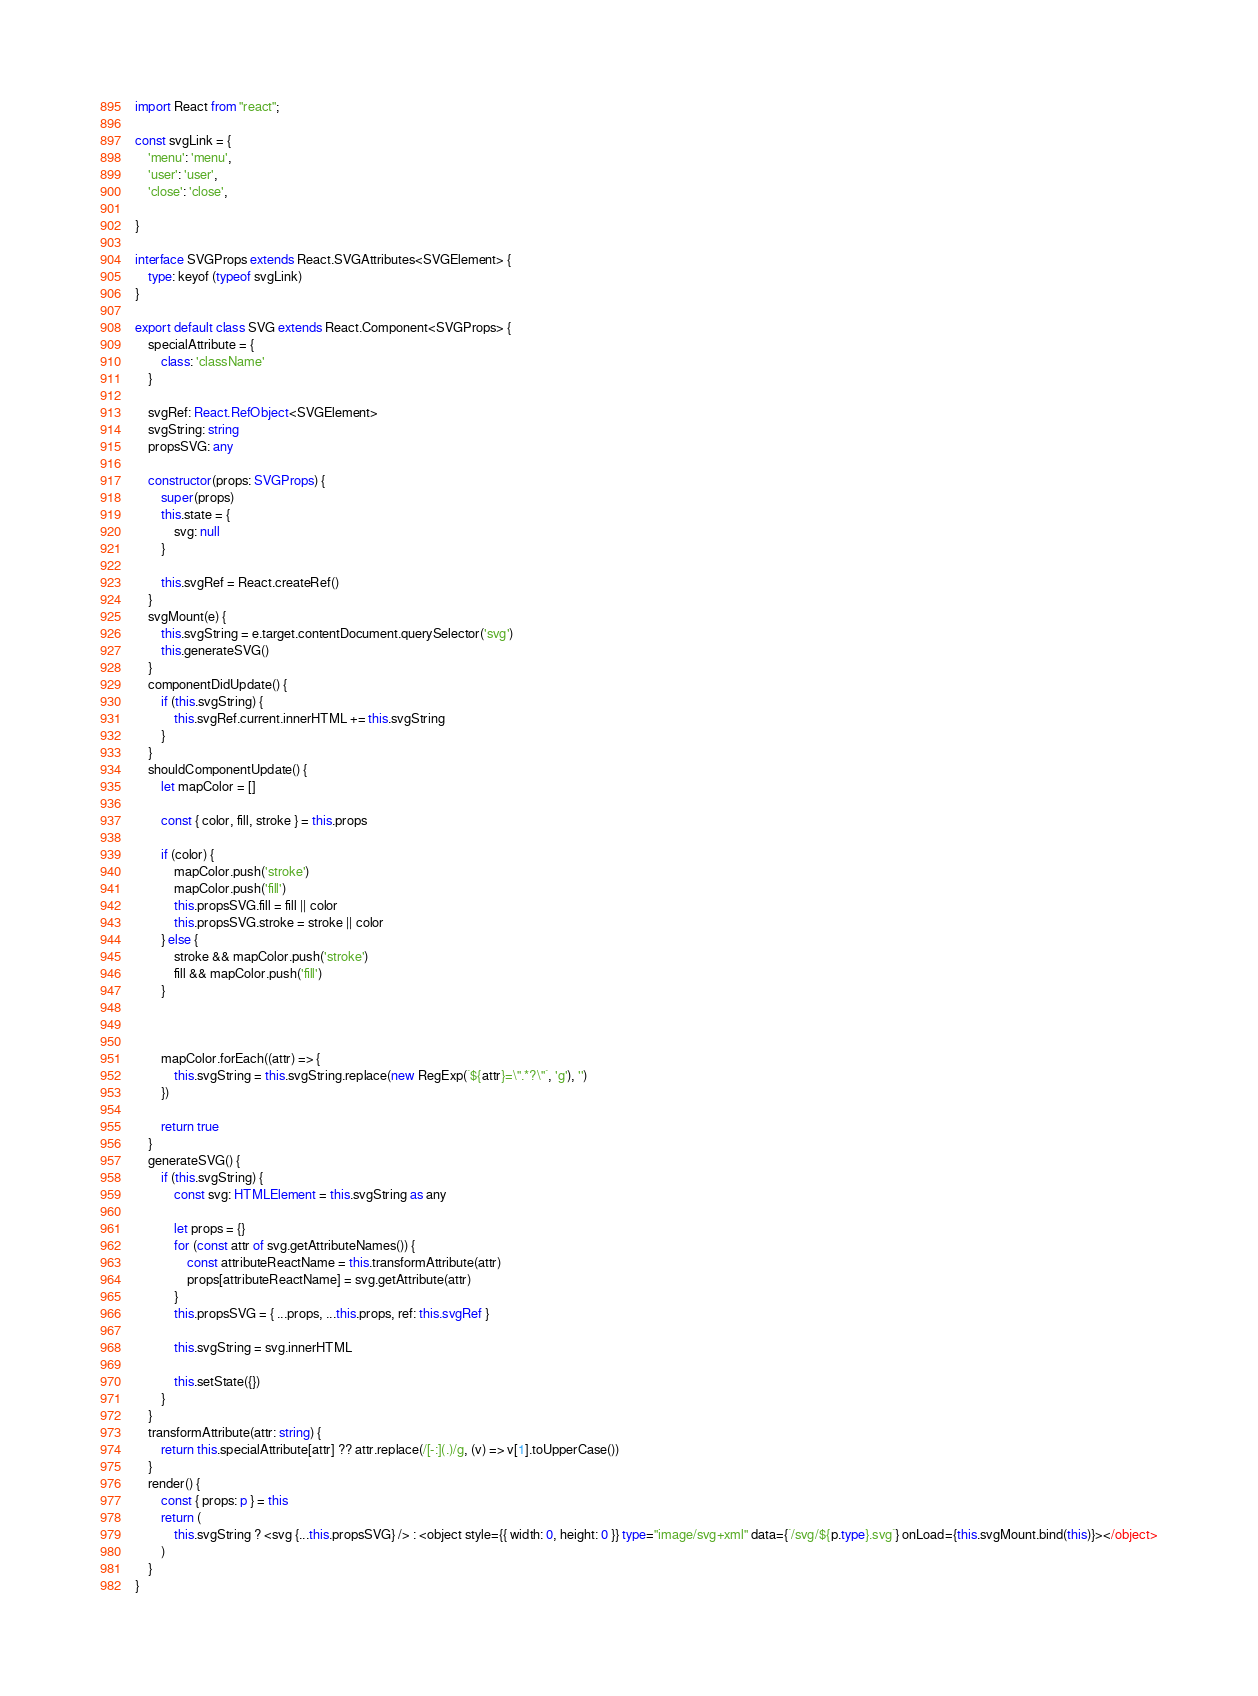Convert code to text. <code><loc_0><loc_0><loc_500><loc_500><_TypeScript_>import React from "react";

const svgLink = {
    'menu': 'menu',
    'user': 'user',
    'close': 'close',

}

interface SVGProps extends React.SVGAttributes<SVGElement> {
    type: keyof (typeof svgLink)
}

export default class SVG extends React.Component<SVGProps> {
    specialAttribute = {
        class: 'className'
    }

    svgRef: React.RefObject<SVGElement>
    svgString: string
    propsSVG: any

    constructor(props: SVGProps) {
        super(props)
        this.state = {
            svg: null
        }

        this.svgRef = React.createRef()
    }
    svgMount(e) {
        this.svgString = e.target.contentDocument.querySelector('svg')
        this.generateSVG()
    }
    componentDidUpdate() {
        if (this.svgString) {
            this.svgRef.current.innerHTML += this.svgString
        }
    }
    shouldComponentUpdate() {
        let mapColor = []

        const { color, fill, stroke } = this.props

        if (color) {
            mapColor.push('stroke')
            mapColor.push('fill')
            this.propsSVG.fill = fill || color
            this.propsSVG.stroke = stroke || color
        } else {
            stroke && mapColor.push('stroke')
            fill && mapColor.push('fill')
        }



        mapColor.forEach((attr) => {
            this.svgString = this.svgString.replace(new RegExp(`${attr}=\".*?\"`, 'g'), '')
        })

        return true
    }
    generateSVG() {
        if (this.svgString) {
            const svg: HTMLElement = this.svgString as any

            let props = {}
            for (const attr of svg.getAttributeNames()) {
                const attributeReactName = this.transformAttribute(attr)
                props[attributeReactName] = svg.getAttribute(attr)
            }
            this.propsSVG = { ...props, ...this.props, ref: this.svgRef }

            this.svgString = svg.innerHTML

            this.setState({})
        }
    }
    transformAttribute(attr: string) {
        return this.specialAttribute[attr] ?? attr.replace(/[-:](.)/g, (v) => v[1].toUpperCase())
    }
    render() {
        const { props: p } = this
        return (
            this.svgString ? <svg {...this.propsSVG} /> : <object style={{ width: 0, height: 0 }} type="image/svg+xml" data={`/svg/${p.type}.svg`} onLoad={this.svgMount.bind(this)}></object>
        )
    }
}</code> 